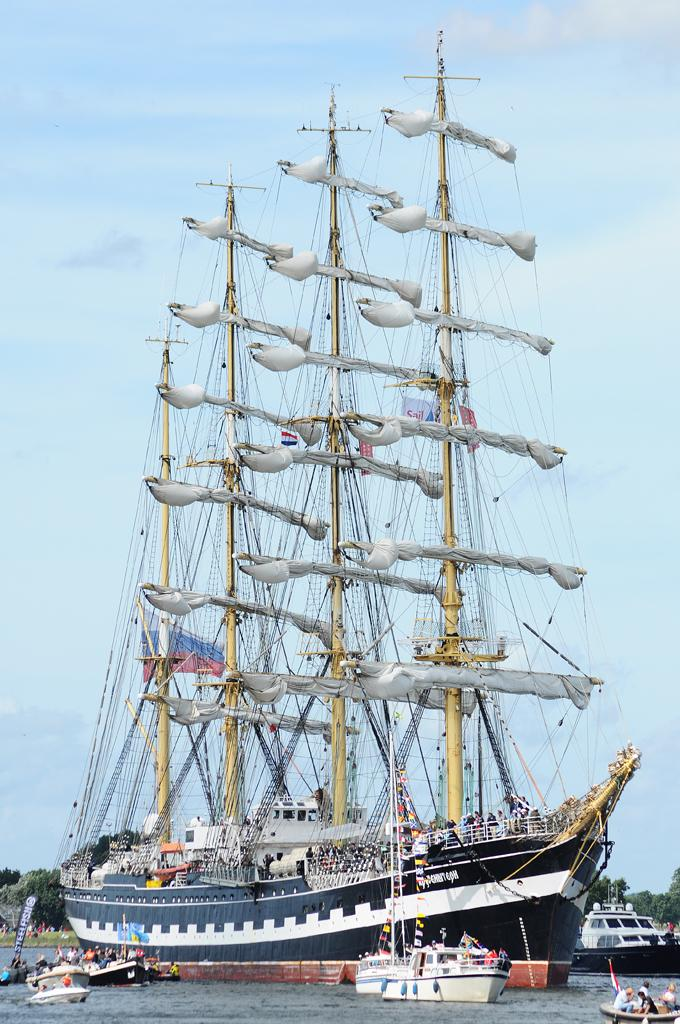<image>
Write a terse but informative summary of the picture. An old fashioned sailing ship is surrounded by much smaller boats and one has a flag that says Steel Fish. 